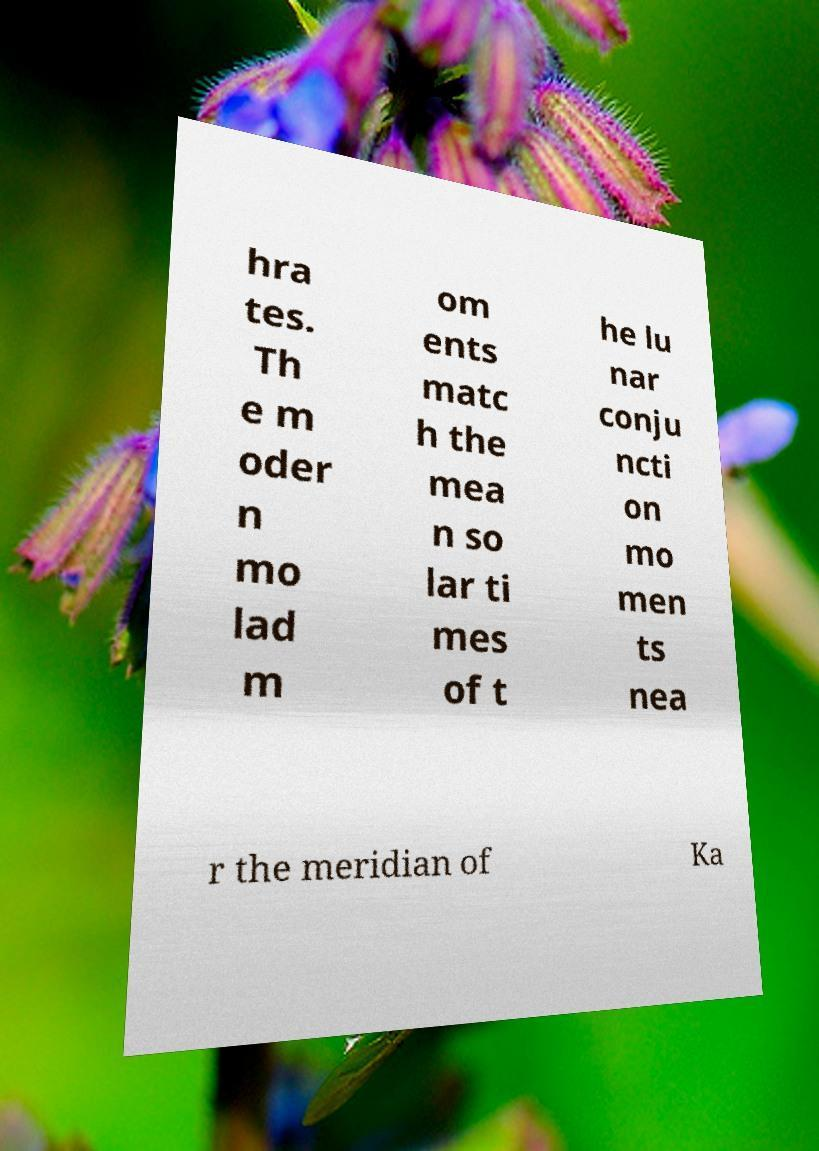Could you assist in decoding the text presented in this image and type it out clearly? hra tes. Th e m oder n mo lad m om ents matc h the mea n so lar ti mes of t he lu nar conju ncti on mo men ts nea r the meridian of Ka 